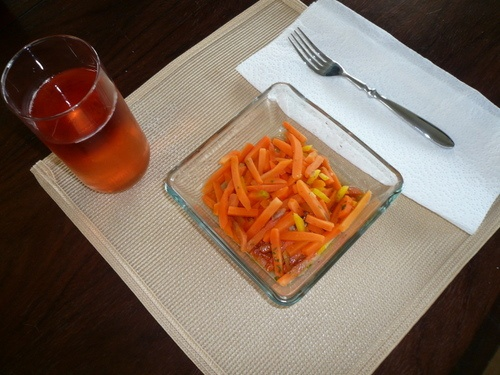Describe the objects in this image and their specific colors. I can see bowl in black, red, tan, and brown tones, cup in black, maroon, and brown tones, carrot in black, red, brown, and orange tones, and fork in black, gray, darkgray, and lightgray tones in this image. 